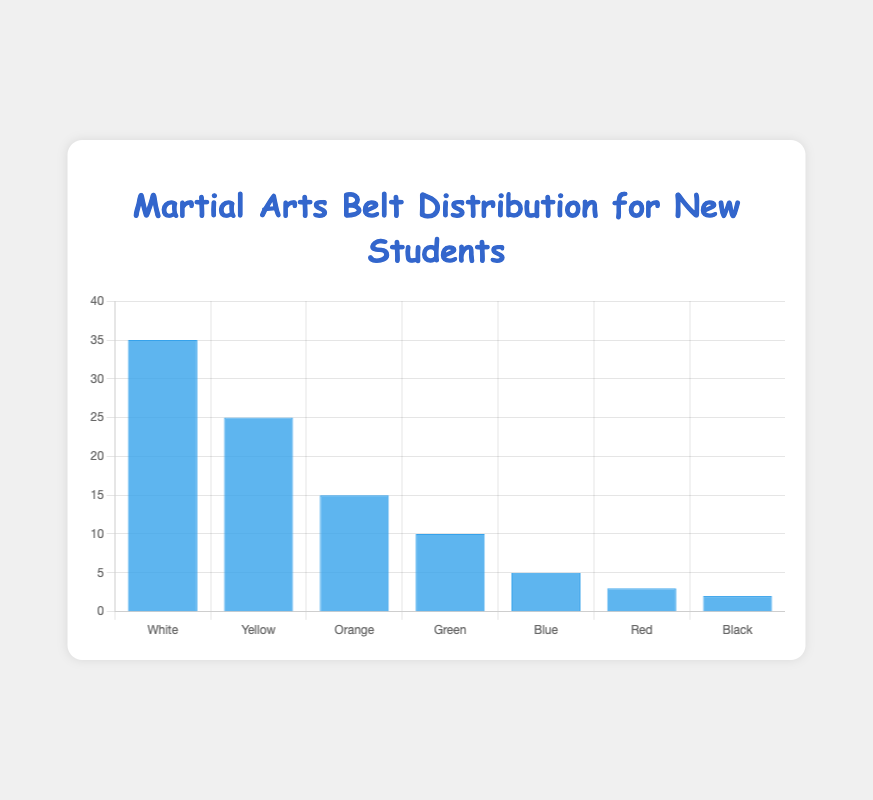What is the number of students with a White belt? The height of the bar labeled "White" on the chart indicates the number of students at this level.
Answer: 35 How many more students have Yellow belts than Blue belts? The number of students with Yellow belts is 25, and the number with Blue belts is 5. The difference is 25 - 5.
Answer: 20 Which belt level has the least number of students? The bar representing the least number of students is the one with the shortest height.
Answer: Black Between which two belt levels is the difference in the number of students the largest? By examining the differences between heights of adjacent bars, the largest difference is between the White belt (35 students) and Yellow belt (25 students).
Answer: White and Yellow What is the total number of students across all belt levels? Sum the individual numbers of students at each belt level: 35 + 25 + 15 + 10 + 5 + 3 + 2.
Answer: 95 What percentage of students are at the Green belt level? The number of Green belt students is 10. The total number of students is 95. Calculate (10 / 95) * 100.
Answer: 10.53% Which belt levels have fewer than 10 students? By observing the chart, the belt levels with fewer than 10 students are Blue, Red, and Black.
Answer: Blue, Red, and Black By how much does the number of White belt students exceed the total number of students in Green, Blue, Red, and Black belts combined? Add the number of students for Green, Blue, Red, and Black belts: 10 + 5 + 3 + 2 = 20. The number of White belt students is 35. Subtract the total number from the number of White belt students: 35 - 20.
Answer: 15 